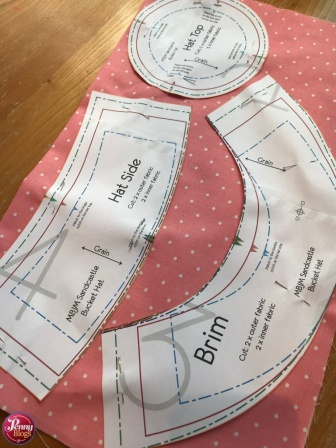If these paper patterns were animated, what kind of conversation might they have about becoming a hat? The Hat Side pattern might start off the conversation with, 'I can't wait to wrap around someone's head and be the centerpiece of this hat!' The Crown pattern could chime in, 'And I'll sit proudly on top, giving the hat its perfect shape!' The Brim pattern would add, 'I'll be the one to shield everyone from the sun, adding flair and function. Together, we'll make the most stylish and practical hat ever!' The patterns would excitedly discuss the transformation, eager to come together in a harmonious creation. Can you narrate a short story set in a magical world where these patterns come to life and embark on an adventure to become a hat? In the enchanted village of Stitchenwood, deep within a mystical forest where threads of magic wove through the air, there lived three magical paper patterns: Hat Side, Crown, and Brim. Each night, as the clock struck midnight, they would come to life, eager to embark on their nightly adventures.

One such night, as the moonlight bathed the atelier in a silvery glow, Hat Side exclaimed, 'Tonight, we must find the legendary Golden Thread to become the finest hat ever made!' With determination in their hearts, they set off on a journey across the village. Crown led the way through the dense, enchanted woods, their path illuminated by fireflies that whispered secrets of the forest.

Brim used its wide, curvy shape to catch the gentle breezes, carrying them swiftly over babbling brooks and through fields of blooming magical flowers. After facing trials and forging friendships with mystical creatures, they finally reached the ancient loom where the Golden Thread was safeguarded by the wise, old Weaver.

The Weaver, impressed by their courage and unity, granted them the Golden Thread. As dawn approached, they hurried back to the atelier. The Weaver’s blessing allowed them to weave a hat that glistened with magical threads, a symbol of their adventure and new-found friendship. When Clara awoke, she found the magnificent hat ready, unaware of the extraordinary journey her patterns had undertaken to achieve this masterpiece.  How might the final hat look and be used in different scenarios? The final hat, created from the pink polka-dotted fabric and precise patterns, would likely be a charming sun hat with a wide brim and a stylish, snug fit. In a casual scenario, it might be worn to a garden party or a beach outing, protecting the wearer from the sun while adding an element of playful fashion.

In a more formal setting, the hat could be accessorized with a matching sash or ribbon, and worn to a high tea or an outdoor wedding, serving both as a practical and an elegant accessory. For a whimsical event, like a vintage fair or a costume party, the hat could be the centerpiece of an ensemble, showcasing the wearer's unique style and appreciation for handcrafted items. Regardless of the occasion, the hat would stand out as a versatile piece, bridging function with fashion and bringing joy to its wearer. 